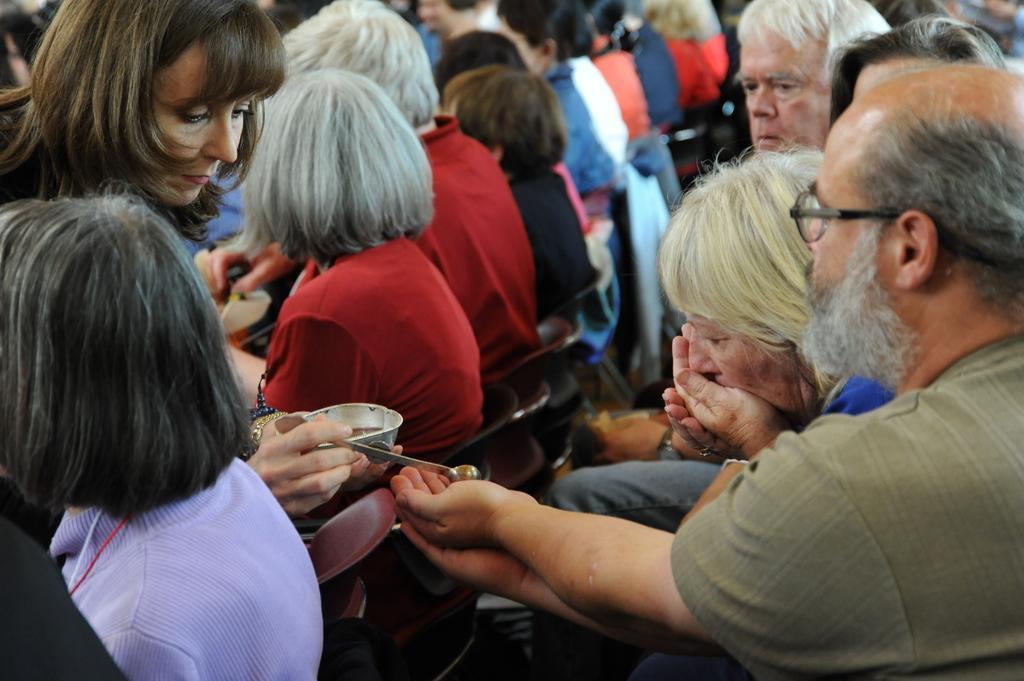How would you summarize this image in a sentence or two? In this image there is a woman who is serving the liquid which is in the bowl with the spoon. On the right side there is a man who kept his hand to take the liquid. In the background there are so many people who are sitting in the chairs. Beside the man there is a woman who is drinking the water. 